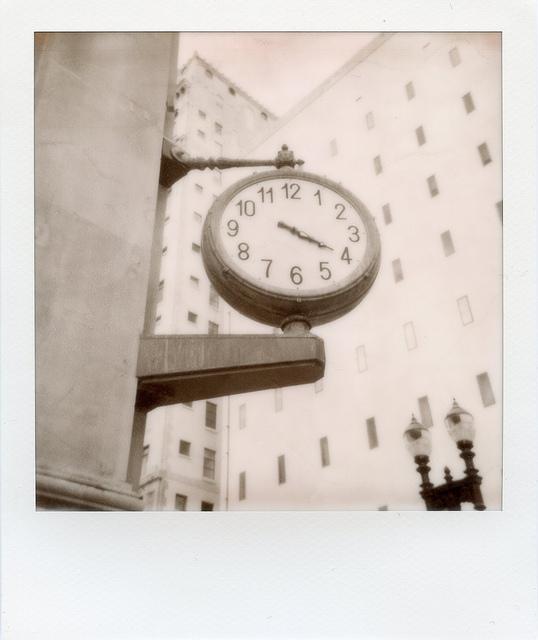What part of the building is the clock posted on?
Answer briefly. Corner. What time is the clock representing?
Short answer required. 4:20. How many lights are in the bottom right?
Write a very short answer. 2. 